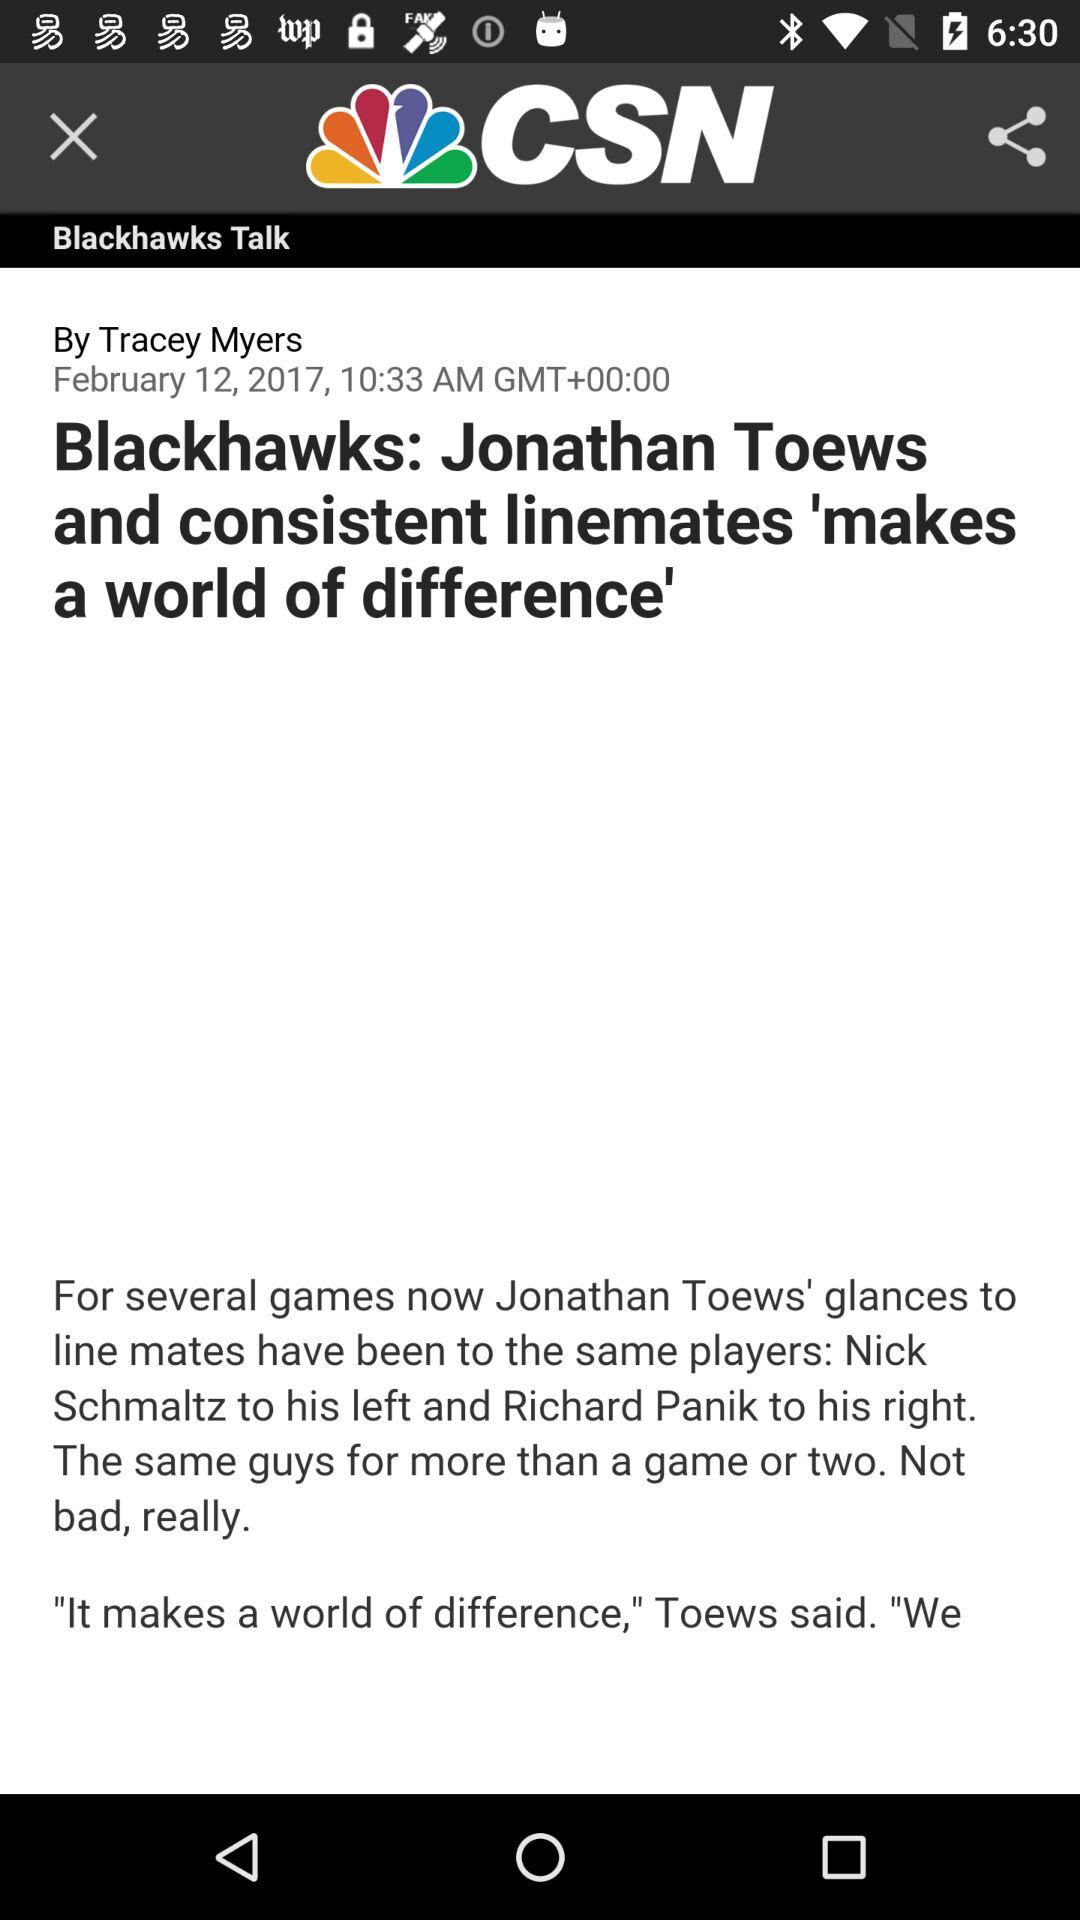Who has uploaded this post? The one who has uploaded this post is Tracey Myers. 